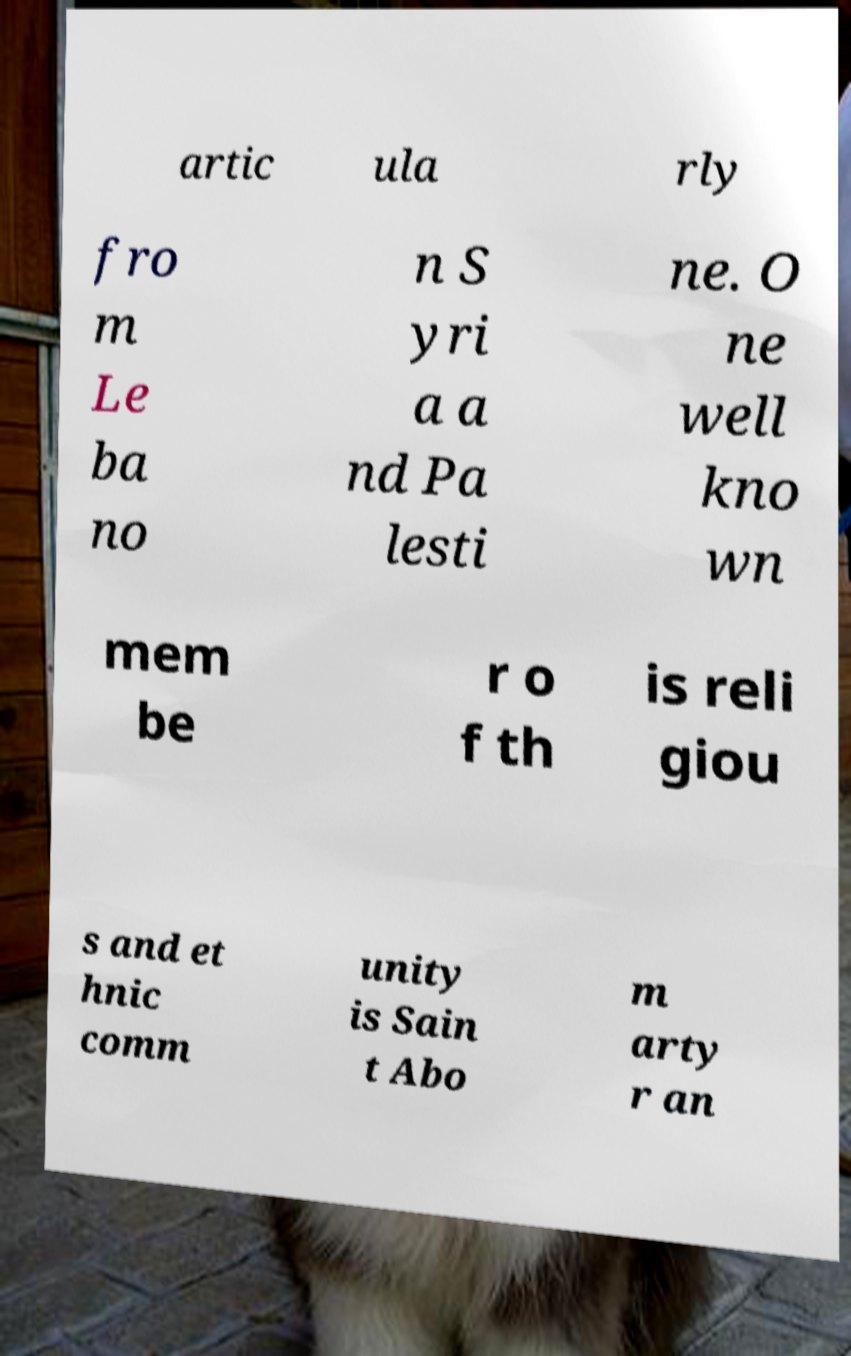Can you accurately transcribe the text from the provided image for me? artic ula rly fro m Le ba no n S yri a a nd Pa lesti ne. O ne well kno wn mem be r o f th is reli giou s and et hnic comm unity is Sain t Abo m arty r an 